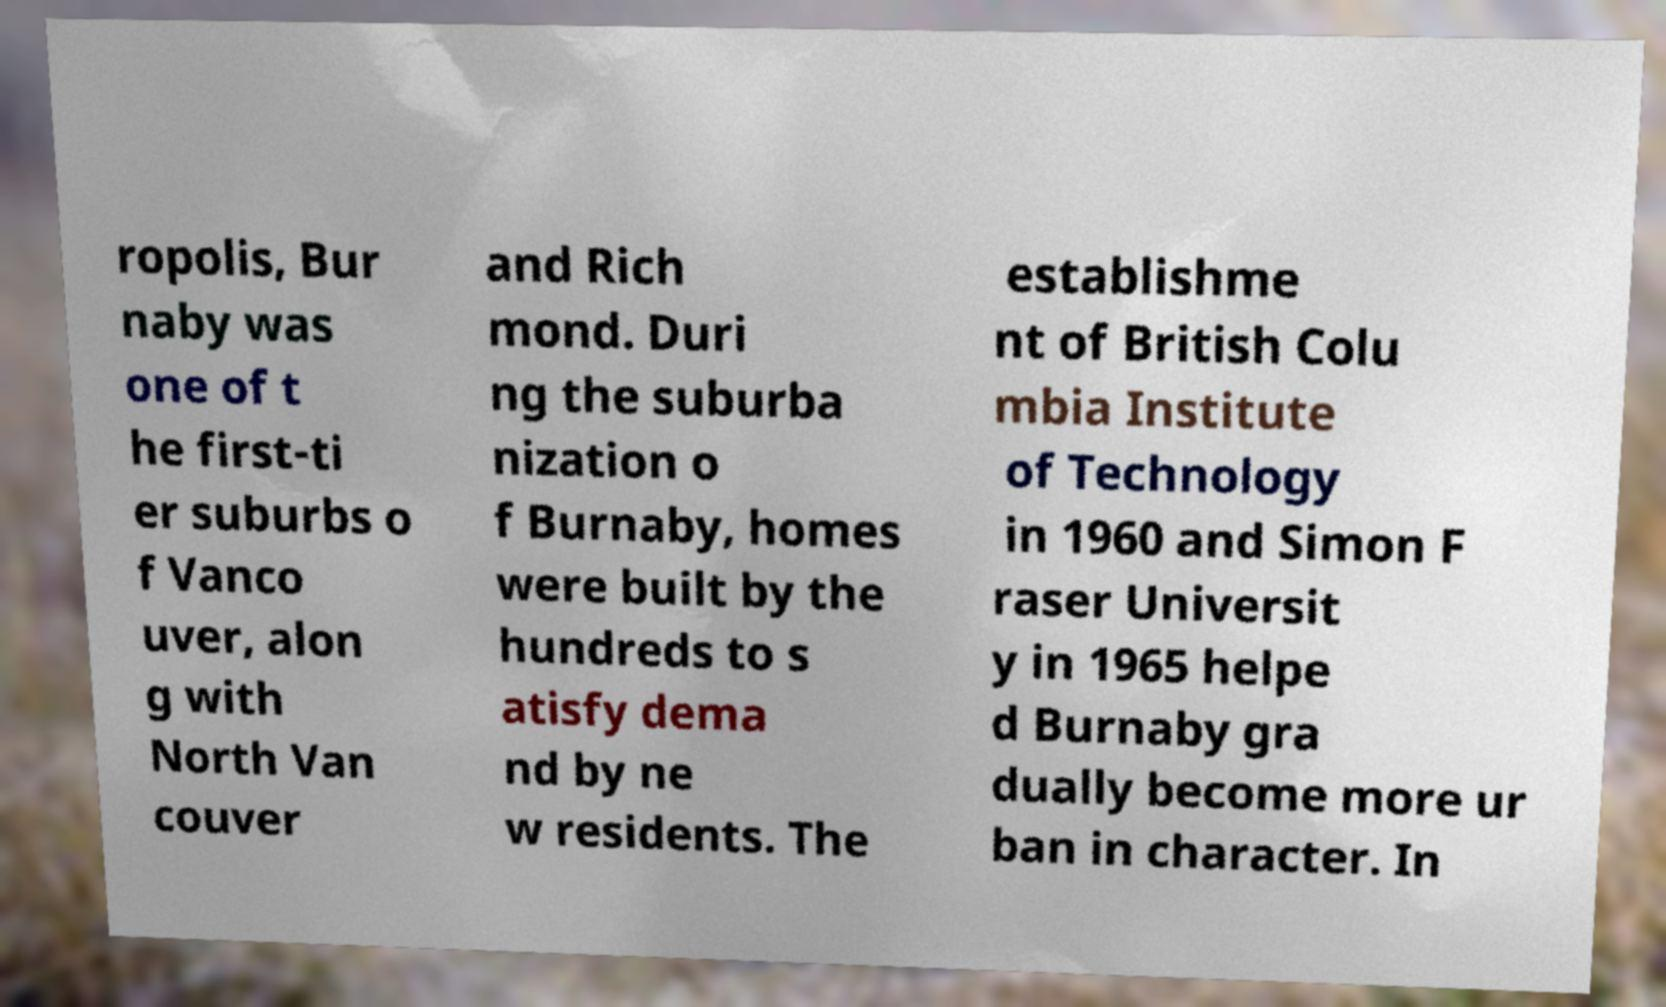What messages or text are displayed in this image? I need them in a readable, typed format. ropolis, Bur naby was one of t he first-ti er suburbs o f Vanco uver, alon g with North Van couver and Rich mond. Duri ng the suburba nization o f Burnaby, homes were built by the hundreds to s atisfy dema nd by ne w residents. The establishme nt of British Colu mbia Institute of Technology in 1960 and Simon F raser Universit y in 1965 helpe d Burnaby gra dually become more ur ban in character. In 